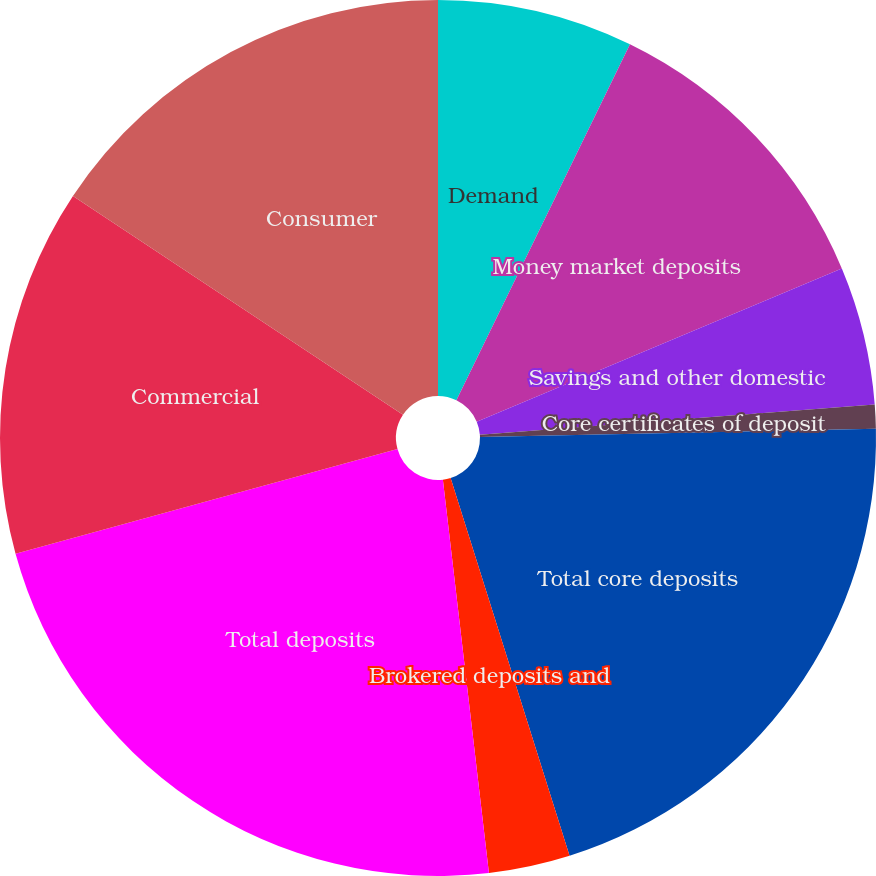Convert chart. <chart><loc_0><loc_0><loc_500><loc_500><pie_chart><fcel>Demand<fcel>Money market deposits<fcel>Savings and other domestic<fcel>Core certificates of deposit<fcel>Total core deposits<fcel>Brokered deposits and<fcel>Total deposits<fcel>Commercial<fcel>Consumer<nl><fcel>7.22%<fcel>11.45%<fcel>5.11%<fcel>0.88%<fcel>20.48%<fcel>3.0%<fcel>22.6%<fcel>13.57%<fcel>15.68%<nl></chart> 